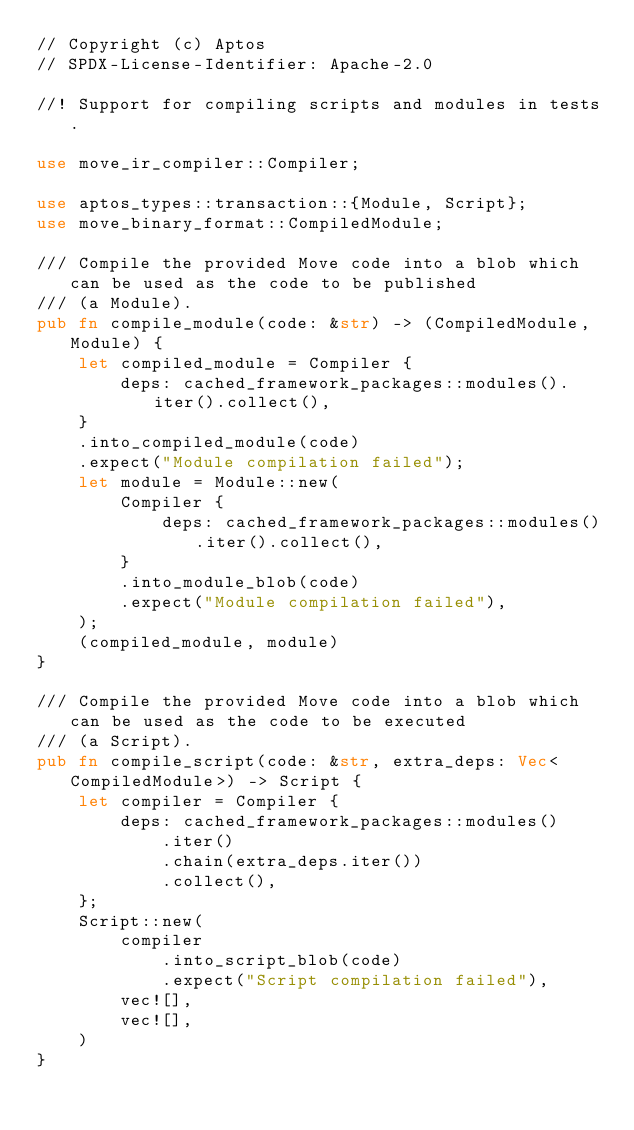<code> <loc_0><loc_0><loc_500><loc_500><_Rust_>// Copyright (c) Aptos
// SPDX-License-Identifier: Apache-2.0

//! Support for compiling scripts and modules in tests.

use move_ir_compiler::Compiler;

use aptos_types::transaction::{Module, Script};
use move_binary_format::CompiledModule;

/// Compile the provided Move code into a blob which can be used as the code to be published
/// (a Module).
pub fn compile_module(code: &str) -> (CompiledModule, Module) {
    let compiled_module = Compiler {
        deps: cached_framework_packages::modules().iter().collect(),
    }
    .into_compiled_module(code)
    .expect("Module compilation failed");
    let module = Module::new(
        Compiler {
            deps: cached_framework_packages::modules().iter().collect(),
        }
        .into_module_blob(code)
        .expect("Module compilation failed"),
    );
    (compiled_module, module)
}

/// Compile the provided Move code into a blob which can be used as the code to be executed
/// (a Script).
pub fn compile_script(code: &str, extra_deps: Vec<CompiledModule>) -> Script {
    let compiler = Compiler {
        deps: cached_framework_packages::modules()
            .iter()
            .chain(extra_deps.iter())
            .collect(),
    };
    Script::new(
        compiler
            .into_script_blob(code)
            .expect("Script compilation failed"),
        vec![],
        vec![],
    )
}
</code> 